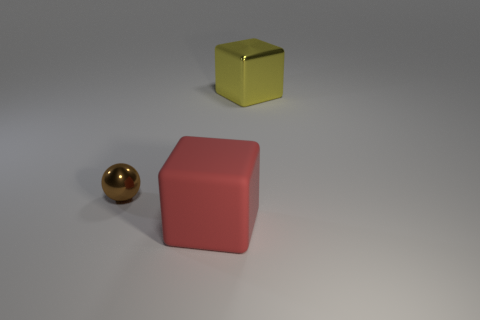Subtract 1 balls. How many balls are left? 0 Add 3 tiny yellow shiny objects. How many objects exist? 6 Subtract all red blocks. How many blocks are left? 1 Subtract all cubes. How many objects are left? 1 Subtract all yellow blocks. How many red spheres are left? 0 Subtract all green blocks. Subtract all blue cylinders. How many blocks are left? 2 Add 2 yellow metallic cubes. How many yellow metallic cubes exist? 3 Subtract 0 cyan cylinders. How many objects are left? 3 Subtract all tiny yellow rubber blocks. Subtract all big things. How many objects are left? 1 Add 1 red blocks. How many red blocks are left? 2 